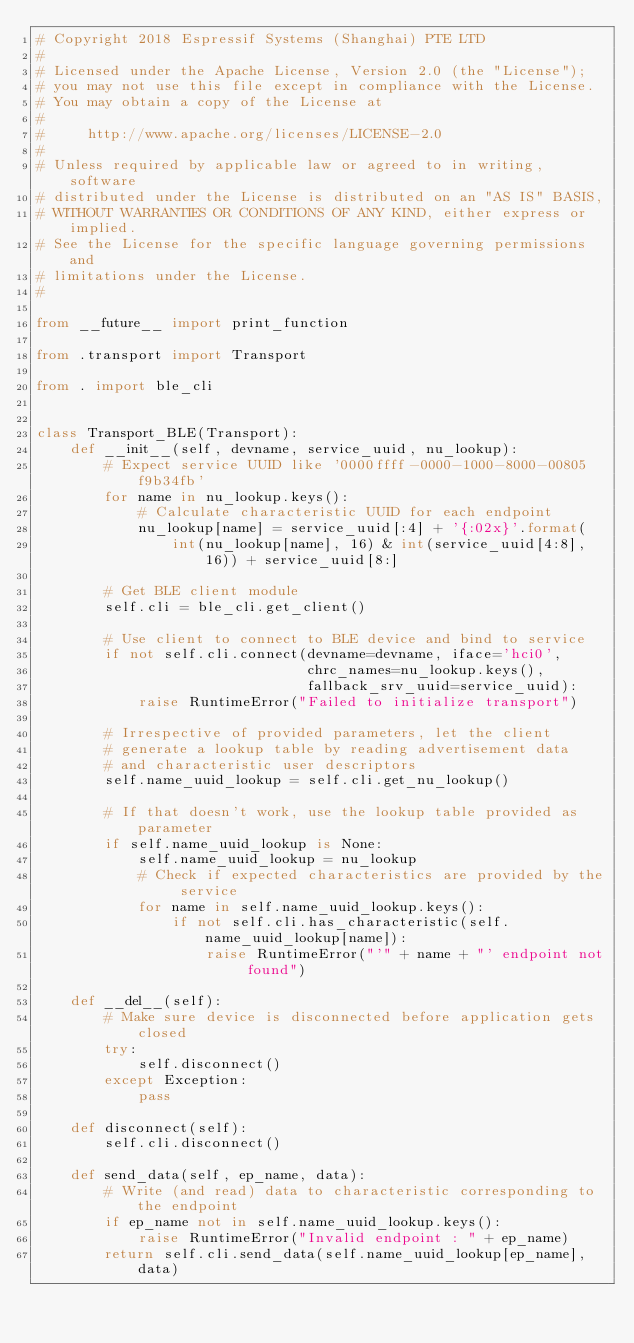Convert code to text. <code><loc_0><loc_0><loc_500><loc_500><_Python_># Copyright 2018 Espressif Systems (Shanghai) PTE LTD
#
# Licensed under the Apache License, Version 2.0 (the "License");
# you may not use this file except in compliance with the License.
# You may obtain a copy of the License at
#
#     http://www.apache.org/licenses/LICENSE-2.0
#
# Unless required by applicable law or agreed to in writing, software
# distributed under the License is distributed on an "AS IS" BASIS,
# WITHOUT WARRANTIES OR CONDITIONS OF ANY KIND, either express or implied.
# See the License for the specific language governing permissions and
# limitations under the License.
#

from __future__ import print_function

from .transport import Transport

from . import ble_cli


class Transport_BLE(Transport):
    def __init__(self, devname, service_uuid, nu_lookup):
        # Expect service UUID like '0000ffff-0000-1000-8000-00805f9b34fb'
        for name in nu_lookup.keys():
            # Calculate characteristic UUID for each endpoint
            nu_lookup[name] = service_uuid[:4] + '{:02x}'.format(
                int(nu_lookup[name], 16) & int(service_uuid[4:8], 16)) + service_uuid[8:]

        # Get BLE client module
        self.cli = ble_cli.get_client()

        # Use client to connect to BLE device and bind to service
        if not self.cli.connect(devname=devname, iface='hci0',
                                chrc_names=nu_lookup.keys(),
                                fallback_srv_uuid=service_uuid):
            raise RuntimeError("Failed to initialize transport")

        # Irrespective of provided parameters, let the client
        # generate a lookup table by reading advertisement data
        # and characteristic user descriptors
        self.name_uuid_lookup = self.cli.get_nu_lookup()

        # If that doesn't work, use the lookup table provided as parameter
        if self.name_uuid_lookup is None:
            self.name_uuid_lookup = nu_lookup
            # Check if expected characteristics are provided by the service
            for name in self.name_uuid_lookup.keys():
                if not self.cli.has_characteristic(self.name_uuid_lookup[name]):
                    raise RuntimeError("'" + name + "' endpoint not found")

    def __del__(self):
        # Make sure device is disconnected before application gets closed
        try:
            self.disconnect()
        except Exception:
            pass

    def disconnect(self):
        self.cli.disconnect()

    def send_data(self, ep_name, data):
        # Write (and read) data to characteristic corresponding to the endpoint
        if ep_name not in self.name_uuid_lookup.keys():
            raise RuntimeError("Invalid endpoint : " + ep_name)
        return self.cli.send_data(self.name_uuid_lookup[ep_name], data)
</code> 